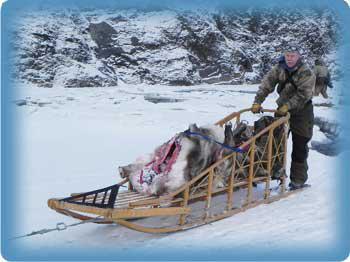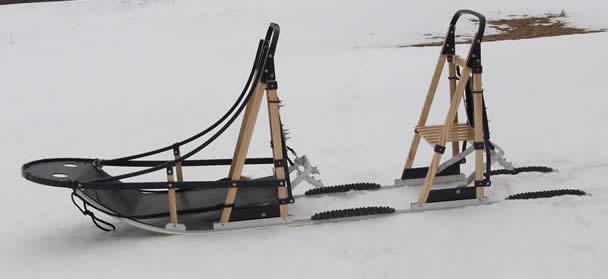The first image is the image on the left, the second image is the image on the right. Assess this claim about the two images: "There is exactly one sled in every photo, with one being made of wood with open design and black bottom and the other made with a tent material that is closed.". Correct or not? Answer yes or no. No. The first image is the image on the left, the second image is the image on the right. Given the left and right images, does the statement "The left image contains an empty, uncovered wood-framed sled with a straight bar for a handle, netting on the sides and a black base, and the right image contains a sled with a nylon cover and curved handle." hold true? Answer yes or no. No. 